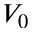<formula> <loc_0><loc_0><loc_500><loc_500>V _ { 0 }</formula> 